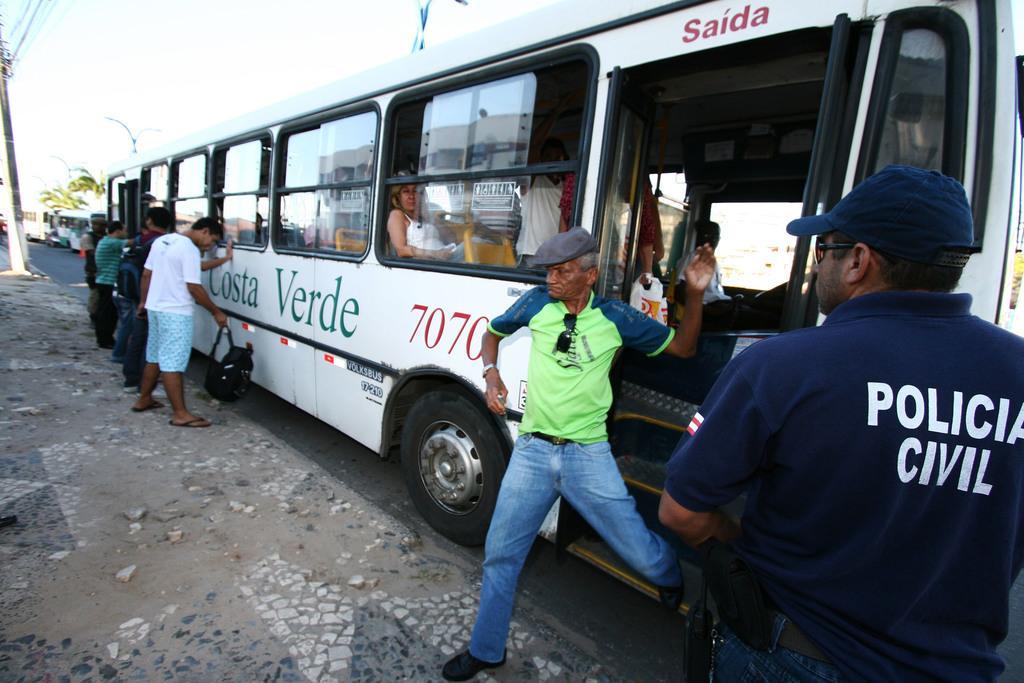In one or two sentences, can you explain what this image depicts? In this picture, on the right side corner, we can see a man wearing a blue color shirt, we can also see a person getting down from the bus. On the right side, we can also see a bus which is in white color, in the bus, we can see few people are sitting. In the middle of the , we can see a group of people standing in front of the people. On the left side, we can see a electrical pole, electrical wires. In the background, we can see some buses, trees, street lights. On the top, we can see a sky, at the bottom there is a road and a land with some stones. 